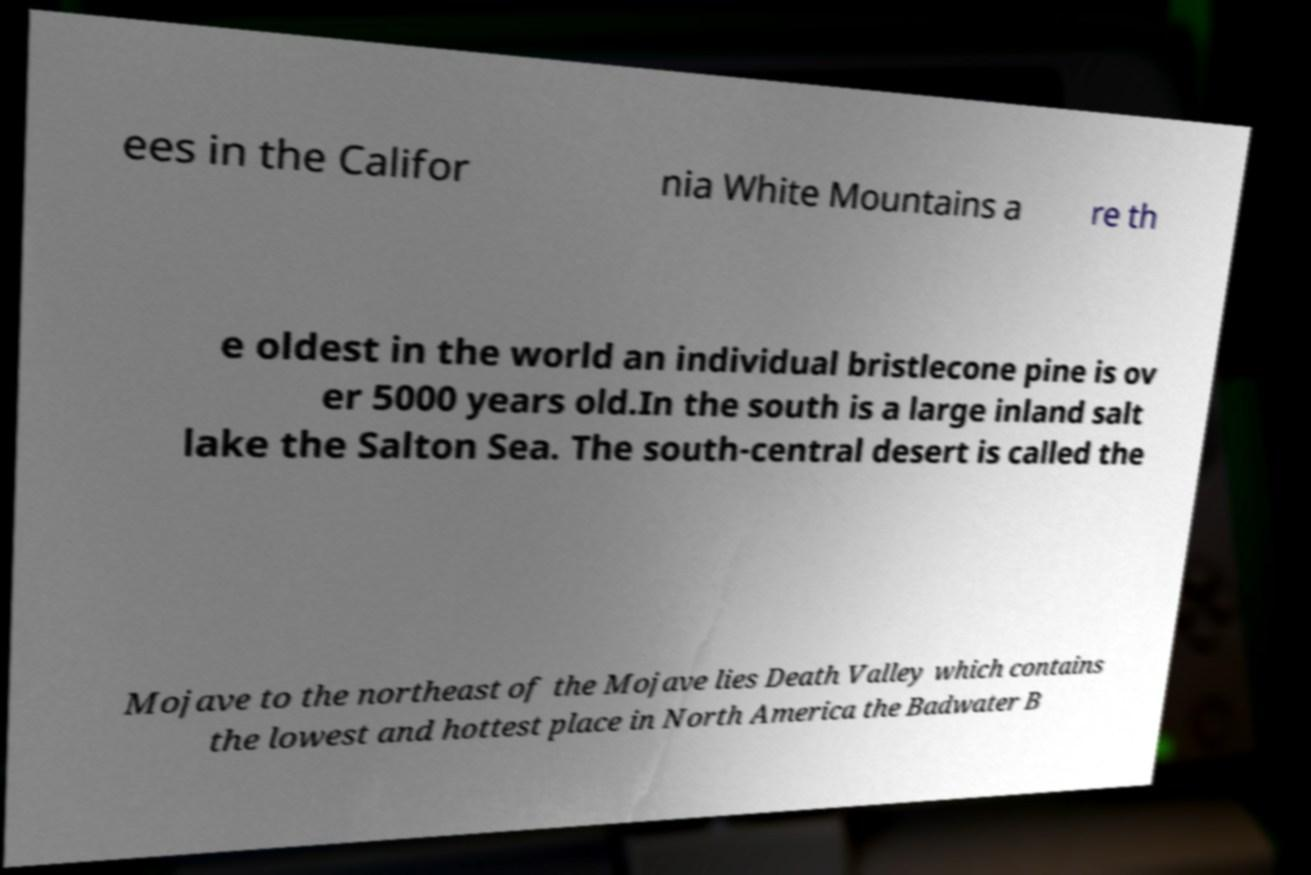Could you extract and type out the text from this image? ees in the Califor nia White Mountains a re th e oldest in the world an individual bristlecone pine is ov er 5000 years old.In the south is a large inland salt lake the Salton Sea. The south-central desert is called the Mojave to the northeast of the Mojave lies Death Valley which contains the lowest and hottest place in North America the Badwater B 